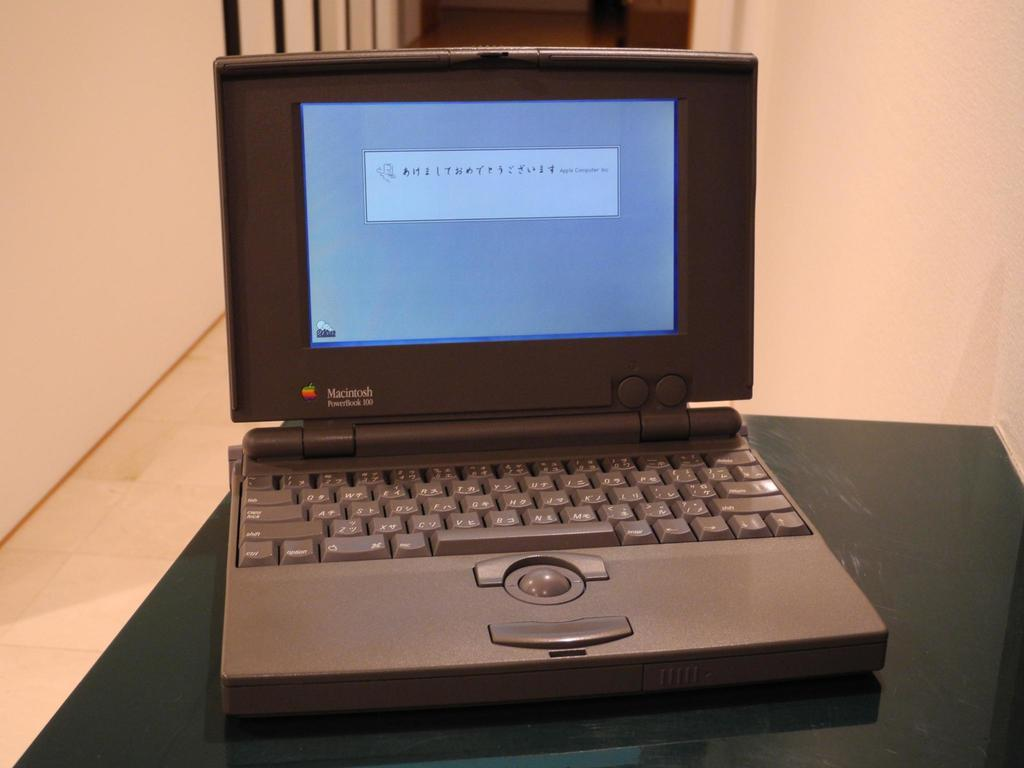<image>
Relay a brief, clear account of the picture shown. A Macintosh Power book 100 sitting on a black marble top table. 